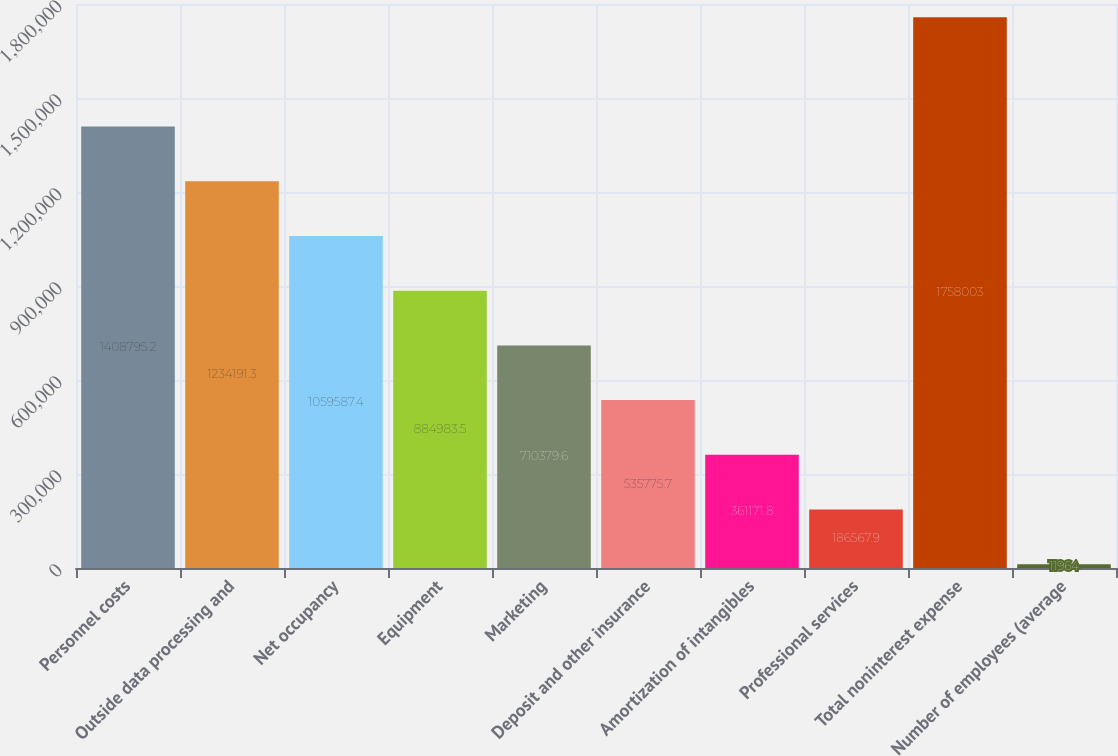<chart> <loc_0><loc_0><loc_500><loc_500><bar_chart><fcel>Personnel costs<fcel>Outside data processing and<fcel>Net occupancy<fcel>Equipment<fcel>Marketing<fcel>Deposit and other insurance<fcel>Amortization of intangibles<fcel>Professional services<fcel>Total noninterest expense<fcel>Number of employees (average<nl><fcel>1.4088e+06<fcel>1.23419e+06<fcel>1.05959e+06<fcel>884984<fcel>710380<fcel>535776<fcel>361172<fcel>186568<fcel>1.758e+06<fcel>11964<nl></chart> 